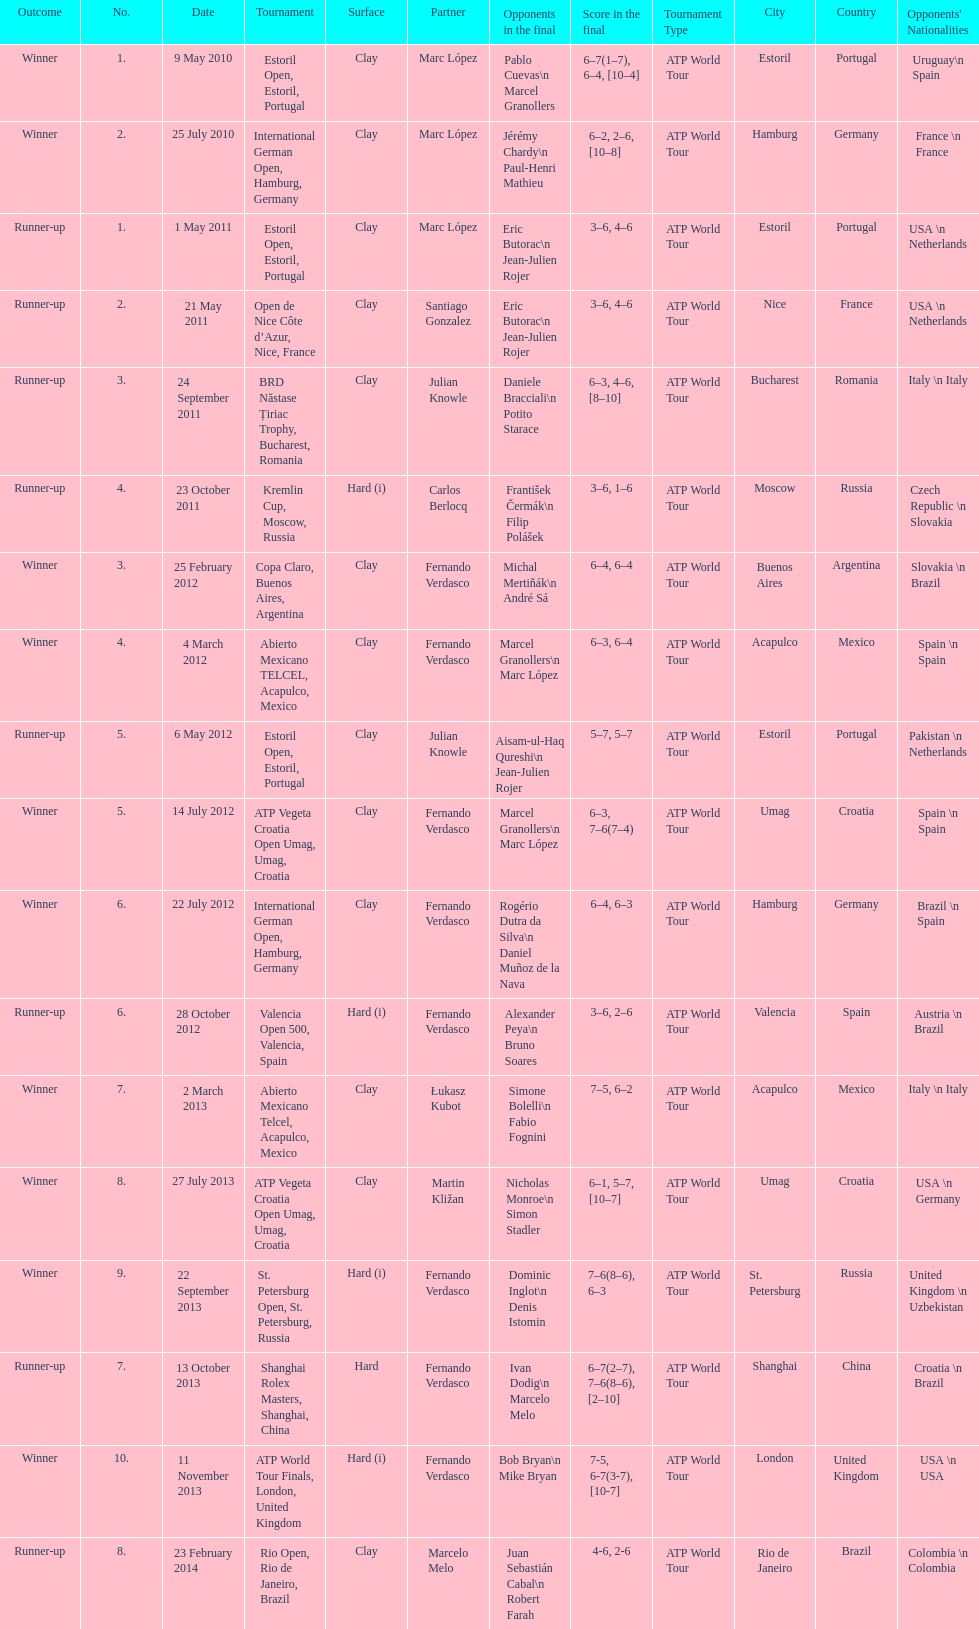What is the sum of runner-ups displayed on the chart? 8. 